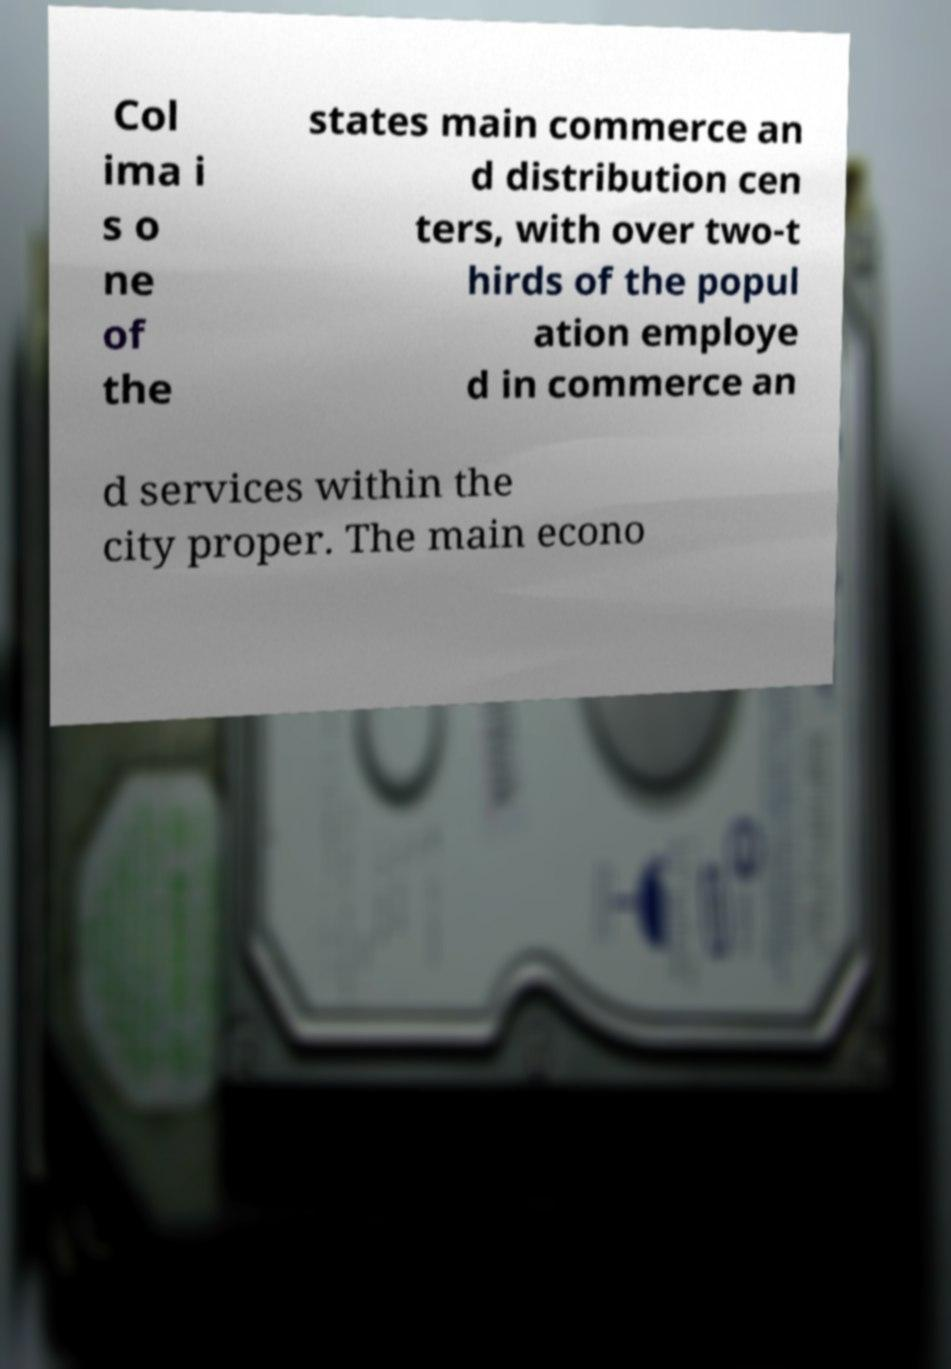Could you assist in decoding the text presented in this image and type it out clearly? Col ima i s o ne of the states main commerce an d distribution cen ters, with over two-t hirds of the popul ation employe d in commerce an d services within the city proper. The main econo 